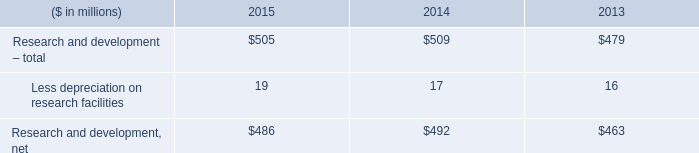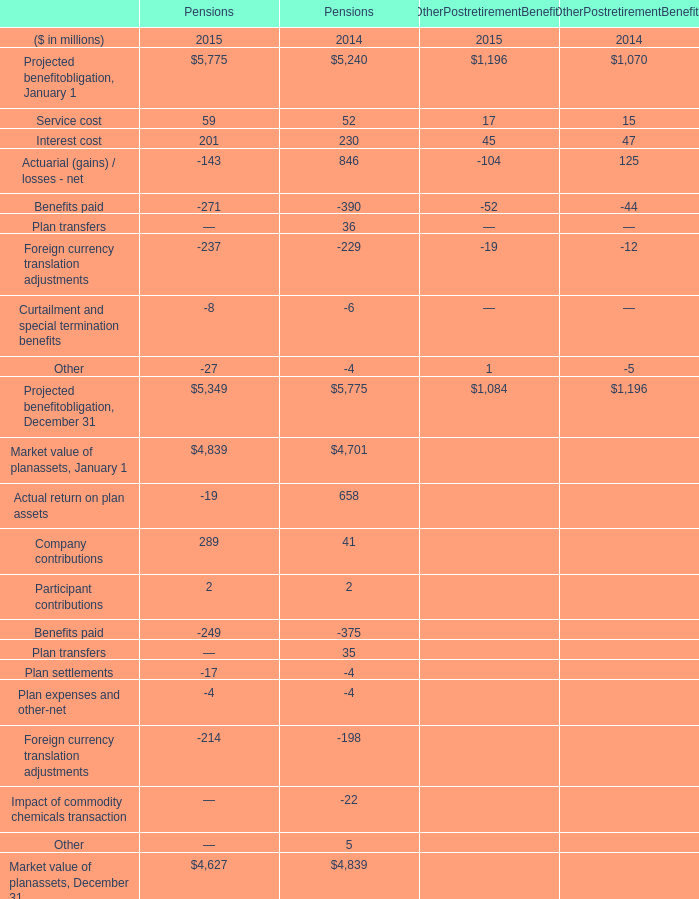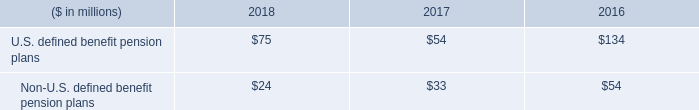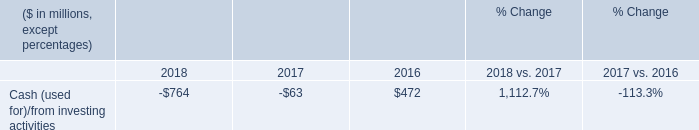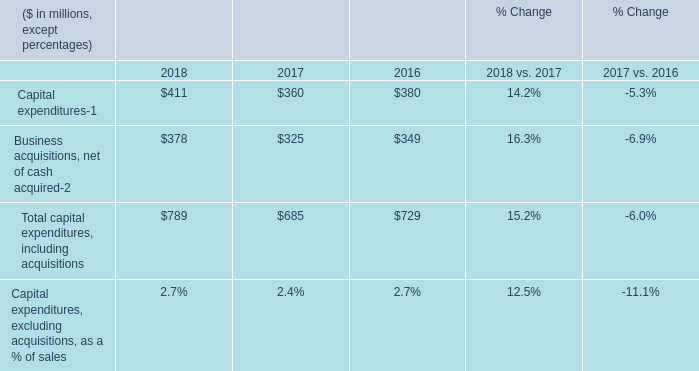What is the average value of Cash (used for)/from investing activities in Table 3 and Total capital expenditures, including acquisitions in Table 4 in 2016? (in millio) 
Computations: ((472 + 729) / 2)
Answer: 600.5. 